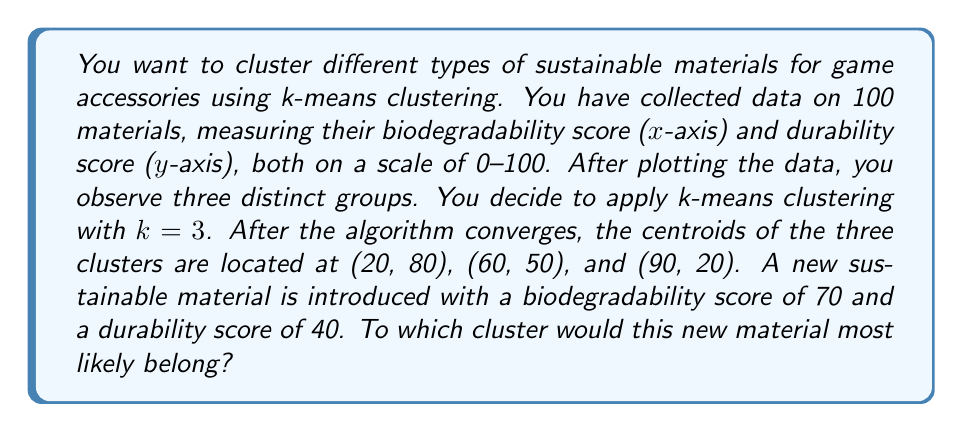Teach me how to tackle this problem. To solve this problem, we need to calculate the Euclidean distance between the new material and each of the three cluster centroids. The new material will be assigned to the cluster with the closest centroid.

Let's denote the new material as $p = (70, 40)$ and the three centroids as:
$c_1 = (20, 80)$
$c_2 = (60, 50)$
$c_3 = (90, 20)$

The Euclidean distance between two points $(x_1, y_1)$ and $(x_2, y_2)$ is given by:

$$ d = \sqrt{(x_2 - x_1)^2 + (y_2 - y_1)^2} $$

Let's calculate the distance between $p$ and each centroid:

1. Distance to $c_1$:
   $$ d_1 = \sqrt{(70 - 20)^2 + (40 - 80)^2} = \sqrt{2500 + 1600} = \sqrt{4100} \approx 64.03 $$

2. Distance to $c_2$:
   $$ d_2 = \sqrt{(70 - 60)^2 + (40 - 50)^2} = \sqrt{100 + 100} = \sqrt{200} \approx 14.14 $$

3. Distance to $c_3$:
   $$ d_3 = \sqrt{(70 - 90)^2 + (40 - 20)^2} = \sqrt{400 + 400} = \sqrt{800} \approx 28.28 $$

The smallest distance is $d_2 \approx 14.14$, which corresponds to the second centroid $c_2 = (60, 50)$.
Answer: The new sustainable material with a biodegradability score of 70 and a durability score of 40 would most likely belong to the cluster with centroid (60, 50). 